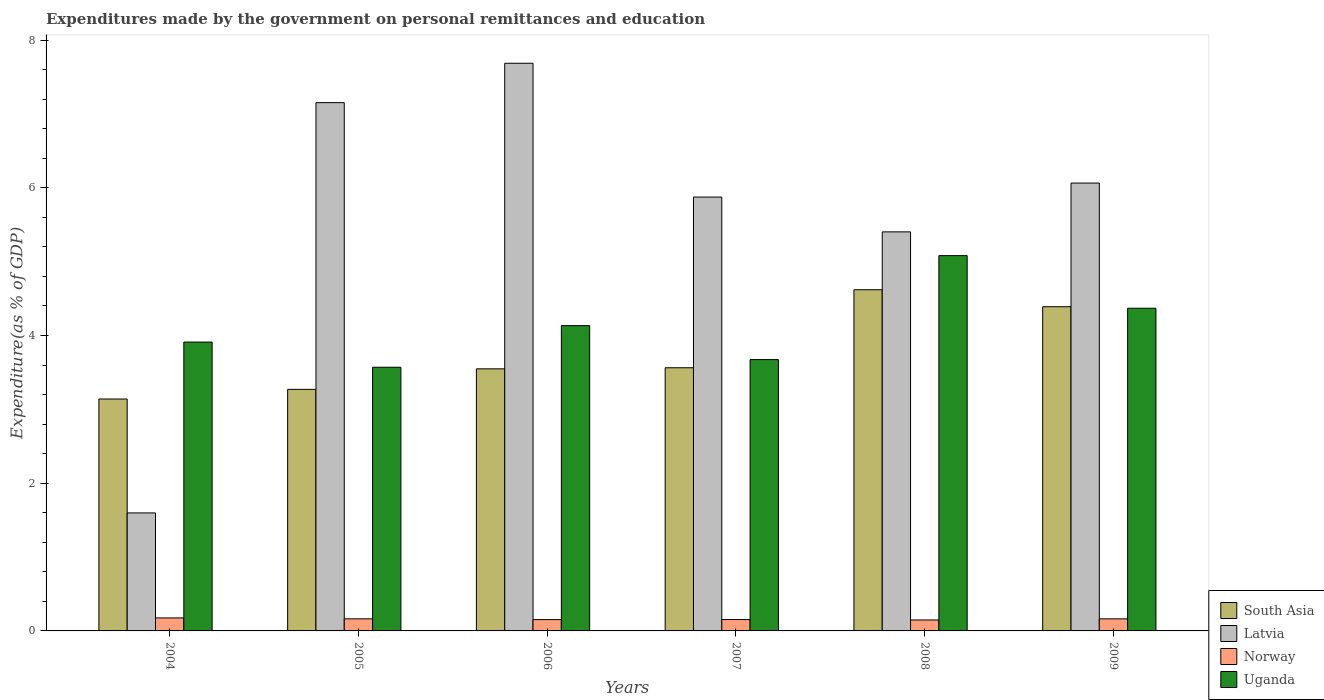Are the number of bars on each tick of the X-axis equal?
Provide a short and direct response. Yes. How many bars are there on the 1st tick from the right?
Provide a short and direct response. 4. In how many cases, is the number of bars for a given year not equal to the number of legend labels?
Give a very brief answer. 0. What is the expenditures made by the government on personal remittances and education in Norway in 2004?
Provide a short and direct response. 0.18. Across all years, what is the maximum expenditures made by the government on personal remittances and education in Latvia?
Provide a short and direct response. 7.69. Across all years, what is the minimum expenditures made by the government on personal remittances and education in Uganda?
Offer a very short reply. 3.57. In which year was the expenditures made by the government on personal remittances and education in Uganda maximum?
Your response must be concise. 2008. What is the total expenditures made by the government on personal remittances and education in Latvia in the graph?
Your response must be concise. 33.78. What is the difference between the expenditures made by the government on personal remittances and education in South Asia in 2004 and that in 2007?
Offer a very short reply. -0.42. What is the difference between the expenditures made by the government on personal remittances and education in Latvia in 2009 and the expenditures made by the government on personal remittances and education in Uganda in 2006?
Keep it short and to the point. 1.93. What is the average expenditures made by the government on personal remittances and education in Uganda per year?
Your answer should be very brief. 4.12. In the year 2008, what is the difference between the expenditures made by the government on personal remittances and education in Latvia and expenditures made by the government on personal remittances and education in South Asia?
Your response must be concise. 0.78. In how many years, is the expenditures made by the government on personal remittances and education in Latvia greater than 2.8 %?
Your answer should be very brief. 5. What is the ratio of the expenditures made by the government on personal remittances and education in Uganda in 2007 to that in 2008?
Make the answer very short. 0.72. Is the expenditures made by the government on personal remittances and education in South Asia in 2004 less than that in 2008?
Give a very brief answer. Yes. Is the difference between the expenditures made by the government on personal remittances and education in Latvia in 2004 and 2009 greater than the difference between the expenditures made by the government on personal remittances and education in South Asia in 2004 and 2009?
Provide a short and direct response. No. What is the difference between the highest and the second highest expenditures made by the government on personal remittances and education in South Asia?
Offer a very short reply. 0.23. What is the difference between the highest and the lowest expenditures made by the government on personal remittances and education in Latvia?
Provide a succinct answer. 6.09. What does the 3rd bar from the left in 2006 represents?
Keep it short and to the point. Norway. Is it the case that in every year, the sum of the expenditures made by the government on personal remittances and education in Latvia and expenditures made by the government on personal remittances and education in Norway is greater than the expenditures made by the government on personal remittances and education in Uganda?
Your answer should be compact. No. How many bars are there?
Keep it short and to the point. 24. How many years are there in the graph?
Offer a terse response. 6. Does the graph contain any zero values?
Provide a short and direct response. No. Does the graph contain grids?
Your answer should be compact. No. How many legend labels are there?
Your answer should be compact. 4. How are the legend labels stacked?
Give a very brief answer. Vertical. What is the title of the graph?
Your answer should be very brief. Expenditures made by the government on personal remittances and education. What is the label or title of the Y-axis?
Give a very brief answer. Expenditure(as % of GDP). What is the Expenditure(as % of GDP) in South Asia in 2004?
Keep it short and to the point. 3.14. What is the Expenditure(as % of GDP) of Latvia in 2004?
Offer a very short reply. 1.6. What is the Expenditure(as % of GDP) in Norway in 2004?
Provide a short and direct response. 0.18. What is the Expenditure(as % of GDP) in Uganda in 2004?
Offer a terse response. 3.91. What is the Expenditure(as % of GDP) of South Asia in 2005?
Ensure brevity in your answer.  3.27. What is the Expenditure(as % of GDP) of Latvia in 2005?
Offer a terse response. 7.15. What is the Expenditure(as % of GDP) of Norway in 2005?
Your answer should be compact. 0.16. What is the Expenditure(as % of GDP) of Uganda in 2005?
Make the answer very short. 3.57. What is the Expenditure(as % of GDP) in South Asia in 2006?
Provide a short and direct response. 3.55. What is the Expenditure(as % of GDP) of Latvia in 2006?
Make the answer very short. 7.69. What is the Expenditure(as % of GDP) in Norway in 2006?
Provide a succinct answer. 0.15. What is the Expenditure(as % of GDP) in Uganda in 2006?
Your answer should be very brief. 4.13. What is the Expenditure(as % of GDP) of South Asia in 2007?
Make the answer very short. 3.56. What is the Expenditure(as % of GDP) of Latvia in 2007?
Give a very brief answer. 5.87. What is the Expenditure(as % of GDP) of Norway in 2007?
Offer a very short reply. 0.15. What is the Expenditure(as % of GDP) in Uganda in 2007?
Offer a very short reply. 3.67. What is the Expenditure(as % of GDP) in South Asia in 2008?
Make the answer very short. 4.62. What is the Expenditure(as % of GDP) of Latvia in 2008?
Provide a short and direct response. 5.4. What is the Expenditure(as % of GDP) of Norway in 2008?
Provide a short and direct response. 0.15. What is the Expenditure(as % of GDP) of Uganda in 2008?
Give a very brief answer. 5.08. What is the Expenditure(as % of GDP) of South Asia in 2009?
Give a very brief answer. 4.39. What is the Expenditure(as % of GDP) in Latvia in 2009?
Your answer should be compact. 6.06. What is the Expenditure(as % of GDP) of Norway in 2009?
Offer a very short reply. 0.16. What is the Expenditure(as % of GDP) of Uganda in 2009?
Offer a very short reply. 4.37. Across all years, what is the maximum Expenditure(as % of GDP) of South Asia?
Offer a very short reply. 4.62. Across all years, what is the maximum Expenditure(as % of GDP) of Latvia?
Your answer should be very brief. 7.69. Across all years, what is the maximum Expenditure(as % of GDP) of Norway?
Give a very brief answer. 0.18. Across all years, what is the maximum Expenditure(as % of GDP) of Uganda?
Your answer should be compact. 5.08. Across all years, what is the minimum Expenditure(as % of GDP) of South Asia?
Offer a very short reply. 3.14. Across all years, what is the minimum Expenditure(as % of GDP) in Latvia?
Your answer should be compact. 1.6. Across all years, what is the minimum Expenditure(as % of GDP) of Norway?
Offer a terse response. 0.15. Across all years, what is the minimum Expenditure(as % of GDP) in Uganda?
Provide a succinct answer. 3.57. What is the total Expenditure(as % of GDP) in South Asia in the graph?
Your response must be concise. 22.53. What is the total Expenditure(as % of GDP) in Latvia in the graph?
Give a very brief answer. 33.78. What is the total Expenditure(as % of GDP) of Norway in the graph?
Offer a terse response. 0.96. What is the total Expenditure(as % of GDP) of Uganda in the graph?
Give a very brief answer. 24.74. What is the difference between the Expenditure(as % of GDP) of South Asia in 2004 and that in 2005?
Provide a short and direct response. -0.13. What is the difference between the Expenditure(as % of GDP) of Latvia in 2004 and that in 2005?
Offer a very short reply. -5.55. What is the difference between the Expenditure(as % of GDP) of Norway in 2004 and that in 2005?
Give a very brief answer. 0.01. What is the difference between the Expenditure(as % of GDP) in Uganda in 2004 and that in 2005?
Ensure brevity in your answer.  0.34. What is the difference between the Expenditure(as % of GDP) in South Asia in 2004 and that in 2006?
Your answer should be very brief. -0.41. What is the difference between the Expenditure(as % of GDP) in Latvia in 2004 and that in 2006?
Your answer should be very brief. -6.09. What is the difference between the Expenditure(as % of GDP) in Norway in 2004 and that in 2006?
Offer a very short reply. 0.02. What is the difference between the Expenditure(as % of GDP) of Uganda in 2004 and that in 2006?
Keep it short and to the point. -0.22. What is the difference between the Expenditure(as % of GDP) in South Asia in 2004 and that in 2007?
Keep it short and to the point. -0.42. What is the difference between the Expenditure(as % of GDP) in Latvia in 2004 and that in 2007?
Provide a succinct answer. -4.28. What is the difference between the Expenditure(as % of GDP) of Norway in 2004 and that in 2007?
Your answer should be compact. 0.02. What is the difference between the Expenditure(as % of GDP) of Uganda in 2004 and that in 2007?
Your answer should be very brief. 0.24. What is the difference between the Expenditure(as % of GDP) in South Asia in 2004 and that in 2008?
Your answer should be compact. -1.48. What is the difference between the Expenditure(as % of GDP) of Latvia in 2004 and that in 2008?
Make the answer very short. -3.81. What is the difference between the Expenditure(as % of GDP) of Norway in 2004 and that in 2008?
Your response must be concise. 0.03. What is the difference between the Expenditure(as % of GDP) in Uganda in 2004 and that in 2008?
Ensure brevity in your answer.  -1.17. What is the difference between the Expenditure(as % of GDP) of South Asia in 2004 and that in 2009?
Make the answer very short. -1.25. What is the difference between the Expenditure(as % of GDP) of Latvia in 2004 and that in 2009?
Provide a succinct answer. -4.47. What is the difference between the Expenditure(as % of GDP) of Norway in 2004 and that in 2009?
Your answer should be compact. 0.01. What is the difference between the Expenditure(as % of GDP) in Uganda in 2004 and that in 2009?
Provide a succinct answer. -0.46. What is the difference between the Expenditure(as % of GDP) of South Asia in 2005 and that in 2006?
Keep it short and to the point. -0.28. What is the difference between the Expenditure(as % of GDP) of Latvia in 2005 and that in 2006?
Provide a short and direct response. -0.53. What is the difference between the Expenditure(as % of GDP) in Norway in 2005 and that in 2006?
Keep it short and to the point. 0.01. What is the difference between the Expenditure(as % of GDP) of Uganda in 2005 and that in 2006?
Offer a very short reply. -0.56. What is the difference between the Expenditure(as % of GDP) of South Asia in 2005 and that in 2007?
Provide a succinct answer. -0.29. What is the difference between the Expenditure(as % of GDP) of Latvia in 2005 and that in 2007?
Your response must be concise. 1.28. What is the difference between the Expenditure(as % of GDP) of Norway in 2005 and that in 2007?
Keep it short and to the point. 0.01. What is the difference between the Expenditure(as % of GDP) of Uganda in 2005 and that in 2007?
Offer a very short reply. -0.1. What is the difference between the Expenditure(as % of GDP) of South Asia in 2005 and that in 2008?
Give a very brief answer. -1.35. What is the difference between the Expenditure(as % of GDP) in Latvia in 2005 and that in 2008?
Make the answer very short. 1.75. What is the difference between the Expenditure(as % of GDP) of Norway in 2005 and that in 2008?
Offer a very short reply. 0.02. What is the difference between the Expenditure(as % of GDP) in Uganda in 2005 and that in 2008?
Offer a terse response. -1.51. What is the difference between the Expenditure(as % of GDP) in South Asia in 2005 and that in 2009?
Your answer should be compact. -1.12. What is the difference between the Expenditure(as % of GDP) of Latvia in 2005 and that in 2009?
Keep it short and to the point. 1.09. What is the difference between the Expenditure(as % of GDP) in Norway in 2005 and that in 2009?
Your answer should be very brief. 0. What is the difference between the Expenditure(as % of GDP) in Uganda in 2005 and that in 2009?
Your answer should be very brief. -0.8. What is the difference between the Expenditure(as % of GDP) in South Asia in 2006 and that in 2007?
Provide a succinct answer. -0.01. What is the difference between the Expenditure(as % of GDP) of Latvia in 2006 and that in 2007?
Offer a very short reply. 1.81. What is the difference between the Expenditure(as % of GDP) in Norway in 2006 and that in 2007?
Keep it short and to the point. -0. What is the difference between the Expenditure(as % of GDP) in Uganda in 2006 and that in 2007?
Make the answer very short. 0.46. What is the difference between the Expenditure(as % of GDP) in South Asia in 2006 and that in 2008?
Your answer should be very brief. -1.07. What is the difference between the Expenditure(as % of GDP) of Latvia in 2006 and that in 2008?
Provide a succinct answer. 2.28. What is the difference between the Expenditure(as % of GDP) in Norway in 2006 and that in 2008?
Offer a very short reply. 0. What is the difference between the Expenditure(as % of GDP) of Uganda in 2006 and that in 2008?
Give a very brief answer. -0.95. What is the difference between the Expenditure(as % of GDP) in South Asia in 2006 and that in 2009?
Offer a terse response. -0.84. What is the difference between the Expenditure(as % of GDP) in Latvia in 2006 and that in 2009?
Provide a short and direct response. 1.62. What is the difference between the Expenditure(as % of GDP) of Norway in 2006 and that in 2009?
Offer a very short reply. -0.01. What is the difference between the Expenditure(as % of GDP) in Uganda in 2006 and that in 2009?
Give a very brief answer. -0.24. What is the difference between the Expenditure(as % of GDP) in South Asia in 2007 and that in 2008?
Make the answer very short. -1.06. What is the difference between the Expenditure(as % of GDP) of Latvia in 2007 and that in 2008?
Offer a terse response. 0.47. What is the difference between the Expenditure(as % of GDP) in Norway in 2007 and that in 2008?
Give a very brief answer. 0.01. What is the difference between the Expenditure(as % of GDP) of Uganda in 2007 and that in 2008?
Keep it short and to the point. -1.41. What is the difference between the Expenditure(as % of GDP) of South Asia in 2007 and that in 2009?
Offer a very short reply. -0.83. What is the difference between the Expenditure(as % of GDP) in Latvia in 2007 and that in 2009?
Give a very brief answer. -0.19. What is the difference between the Expenditure(as % of GDP) of Norway in 2007 and that in 2009?
Make the answer very short. -0.01. What is the difference between the Expenditure(as % of GDP) of Uganda in 2007 and that in 2009?
Offer a very short reply. -0.7. What is the difference between the Expenditure(as % of GDP) in South Asia in 2008 and that in 2009?
Offer a very short reply. 0.23. What is the difference between the Expenditure(as % of GDP) in Latvia in 2008 and that in 2009?
Make the answer very short. -0.66. What is the difference between the Expenditure(as % of GDP) of Norway in 2008 and that in 2009?
Offer a very short reply. -0.02. What is the difference between the Expenditure(as % of GDP) of Uganda in 2008 and that in 2009?
Provide a succinct answer. 0.71. What is the difference between the Expenditure(as % of GDP) of South Asia in 2004 and the Expenditure(as % of GDP) of Latvia in 2005?
Offer a terse response. -4.01. What is the difference between the Expenditure(as % of GDP) of South Asia in 2004 and the Expenditure(as % of GDP) of Norway in 2005?
Provide a short and direct response. 2.98. What is the difference between the Expenditure(as % of GDP) of South Asia in 2004 and the Expenditure(as % of GDP) of Uganda in 2005?
Your answer should be very brief. -0.43. What is the difference between the Expenditure(as % of GDP) in Latvia in 2004 and the Expenditure(as % of GDP) in Norway in 2005?
Provide a short and direct response. 1.43. What is the difference between the Expenditure(as % of GDP) in Latvia in 2004 and the Expenditure(as % of GDP) in Uganda in 2005?
Keep it short and to the point. -1.97. What is the difference between the Expenditure(as % of GDP) of Norway in 2004 and the Expenditure(as % of GDP) of Uganda in 2005?
Ensure brevity in your answer.  -3.39. What is the difference between the Expenditure(as % of GDP) in South Asia in 2004 and the Expenditure(as % of GDP) in Latvia in 2006?
Provide a succinct answer. -4.55. What is the difference between the Expenditure(as % of GDP) in South Asia in 2004 and the Expenditure(as % of GDP) in Norway in 2006?
Your answer should be very brief. 2.99. What is the difference between the Expenditure(as % of GDP) of South Asia in 2004 and the Expenditure(as % of GDP) of Uganda in 2006?
Your answer should be compact. -0.99. What is the difference between the Expenditure(as % of GDP) in Latvia in 2004 and the Expenditure(as % of GDP) in Norway in 2006?
Your response must be concise. 1.44. What is the difference between the Expenditure(as % of GDP) of Latvia in 2004 and the Expenditure(as % of GDP) of Uganda in 2006?
Your response must be concise. -2.54. What is the difference between the Expenditure(as % of GDP) in Norway in 2004 and the Expenditure(as % of GDP) in Uganda in 2006?
Keep it short and to the point. -3.96. What is the difference between the Expenditure(as % of GDP) of South Asia in 2004 and the Expenditure(as % of GDP) of Latvia in 2007?
Provide a succinct answer. -2.73. What is the difference between the Expenditure(as % of GDP) in South Asia in 2004 and the Expenditure(as % of GDP) in Norway in 2007?
Your answer should be compact. 2.99. What is the difference between the Expenditure(as % of GDP) in South Asia in 2004 and the Expenditure(as % of GDP) in Uganda in 2007?
Make the answer very short. -0.53. What is the difference between the Expenditure(as % of GDP) of Latvia in 2004 and the Expenditure(as % of GDP) of Norway in 2007?
Give a very brief answer. 1.44. What is the difference between the Expenditure(as % of GDP) of Latvia in 2004 and the Expenditure(as % of GDP) of Uganda in 2007?
Keep it short and to the point. -2.08. What is the difference between the Expenditure(as % of GDP) of Norway in 2004 and the Expenditure(as % of GDP) of Uganda in 2007?
Provide a succinct answer. -3.5. What is the difference between the Expenditure(as % of GDP) of South Asia in 2004 and the Expenditure(as % of GDP) of Latvia in 2008?
Provide a short and direct response. -2.26. What is the difference between the Expenditure(as % of GDP) in South Asia in 2004 and the Expenditure(as % of GDP) in Norway in 2008?
Provide a succinct answer. 2.99. What is the difference between the Expenditure(as % of GDP) in South Asia in 2004 and the Expenditure(as % of GDP) in Uganda in 2008?
Ensure brevity in your answer.  -1.94. What is the difference between the Expenditure(as % of GDP) in Latvia in 2004 and the Expenditure(as % of GDP) in Norway in 2008?
Your response must be concise. 1.45. What is the difference between the Expenditure(as % of GDP) in Latvia in 2004 and the Expenditure(as % of GDP) in Uganda in 2008?
Your answer should be very brief. -3.48. What is the difference between the Expenditure(as % of GDP) of Norway in 2004 and the Expenditure(as % of GDP) of Uganda in 2008?
Your answer should be compact. -4.91. What is the difference between the Expenditure(as % of GDP) of South Asia in 2004 and the Expenditure(as % of GDP) of Latvia in 2009?
Your answer should be very brief. -2.92. What is the difference between the Expenditure(as % of GDP) in South Asia in 2004 and the Expenditure(as % of GDP) in Norway in 2009?
Keep it short and to the point. 2.98. What is the difference between the Expenditure(as % of GDP) in South Asia in 2004 and the Expenditure(as % of GDP) in Uganda in 2009?
Your response must be concise. -1.23. What is the difference between the Expenditure(as % of GDP) in Latvia in 2004 and the Expenditure(as % of GDP) in Norway in 2009?
Provide a succinct answer. 1.43. What is the difference between the Expenditure(as % of GDP) in Latvia in 2004 and the Expenditure(as % of GDP) in Uganda in 2009?
Your answer should be compact. -2.77. What is the difference between the Expenditure(as % of GDP) of Norway in 2004 and the Expenditure(as % of GDP) of Uganda in 2009?
Offer a terse response. -4.19. What is the difference between the Expenditure(as % of GDP) in South Asia in 2005 and the Expenditure(as % of GDP) in Latvia in 2006?
Your response must be concise. -4.42. What is the difference between the Expenditure(as % of GDP) of South Asia in 2005 and the Expenditure(as % of GDP) of Norway in 2006?
Your answer should be compact. 3.12. What is the difference between the Expenditure(as % of GDP) in South Asia in 2005 and the Expenditure(as % of GDP) in Uganda in 2006?
Provide a succinct answer. -0.86. What is the difference between the Expenditure(as % of GDP) of Latvia in 2005 and the Expenditure(as % of GDP) of Norway in 2006?
Give a very brief answer. 7. What is the difference between the Expenditure(as % of GDP) in Latvia in 2005 and the Expenditure(as % of GDP) in Uganda in 2006?
Provide a succinct answer. 3.02. What is the difference between the Expenditure(as % of GDP) of Norway in 2005 and the Expenditure(as % of GDP) of Uganda in 2006?
Offer a terse response. -3.97. What is the difference between the Expenditure(as % of GDP) in South Asia in 2005 and the Expenditure(as % of GDP) in Latvia in 2007?
Provide a succinct answer. -2.6. What is the difference between the Expenditure(as % of GDP) of South Asia in 2005 and the Expenditure(as % of GDP) of Norway in 2007?
Offer a terse response. 3.12. What is the difference between the Expenditure(as % of GDP) of South Asia in 2005 and the Expenditure(as % of GDP) of Uganda in 2007?
Make the answer very short. -0.4. What is the difference between the Expenditure(as % of GDP) in Latvia in 2005 and the Expenditure(as % of GDP) in Norway in 2007?
Your answer should be compact. 7. What is the difference between the Expenditure(as % of GDP) of Latvia in 2005 and the Expenditure(as % of GDP) of Uganda in 2007?
Ensure brevity in your answer.  3.48. What is the difference between the Expenditure(as % of GDP) in Norway in 2005 and the Expenditure(as % of GDP) in Uganda in 2007?
Offer a terse response. -3.51. What is the difference between the Expenditure(as % of GDP) in South Asia in 2005 and the Expenditure(as % of GDP) in Latvia in 2008?
Keep it short and to the point. -2.13. What is the difference between the Expenditure(as % of GDP) of South Asia in 2005 and the Expenditure(as % of GDP) of Norway in 2008?
Ensure brevity in your answer.  3.12. What is the difference between the Expenditure(as % of GDP) of South Asia in 2005 and the Expenditure(as % of GDP) of Uganda in 2008?
Give a very brief answer. -1.81. What is the difference between the Expenditure(as % of GDP) in Latvia in 2005 and the Expenditure(as % of GDP) in Norway in 2008?
Your answer should be compact. 7. What is the difference between the Expenditure(as % of GDP) in Latvia in 2005 and the Expenditure(as % of GDP) in Uganda in 2008?
Your response must be concise. 2.07. What is the difference between the Expenditure(as % of GDP) in Norway in 2005 and the Expenditure(as % of GDP) in Uganda in 2008?
Offer a very short reply. -4.92. What is the difference between the Expenditure(as % of GDP) in South Asia in 2005 and the Expenditure(as % of GDP) in Latvia in 2009?
Keep it short and to the point. -2.79. What is the difference between the Expenditure(as % of GDP) of South Asia in 2005 and the Expenditure(as % of GDP) of Norway in 2009?
Make the answer very short. 3.11. What is the difference between the Expenditure(as % of GDP) in South Asia in 2005 and the Expenditure(as % of GDP) in Uganda in 2009?
Offer a terse response. -1.1. What is the difference between the Expenditure(as % of GDP) of Latvia in 2005 and the Expenditure(as % of GDP) of Norway in 2009?
Offer a terse response. 6.99. What is the difference between the Expenditure(as % of GDP) of Latvia in 2005 and the Expenditure(as % of GDP) of Uganda in 2009?
Your response must be concise. 2.78. What is the difference between the Expenditure(as % of GDP) in Norway in 2005 and the Expenditure(as % of GDP) in Uganda in 2009?
Ensure brevity in your answer.  -4.21. What is the difference between the Expenditure(as % of GDP) of South Asia in 2006 and the Expenditure(as % of GDP) of Latvia in 2007?
Provide a succinct answer. -2.33. What is the difference between the Expenditure(as % of GDP) in South Asia in 2006 and the Expenditure(as % of GDP) in Norway in 2007?
Offer a very short reply. 3.39. What is the difference between the Expenditure(as % of GDP) in South Asia in 2006 and the Expenditure(as % of GDP) in Uganda in 2007?
Provide a short and direct response. -0.12. What is the difference between the Expenditure(as % of GDP) in Latvia in 2006 and the Expenditure(as % of GDP) in Norway in 2007?
Make the answer very short. 7.53. What is the difference between the Expenditure(as % of GDP) in Latvia in 2006 and the Expenditure(as % of GDP) in Uganda in 2007?
Ensure brevity in your answer.  4.01. What is the difference between the Expenditure(as % of GDP) in Norway in 2006 and the Expenditure(as % of GDP) in Uganda in 2007?
Give a very brief answer. -3.52. What is the difference between the Expenditure(as % of GDP) in South Asia in 2006 and the Expenditure(as % of GDP) in Latvia in 2008?
Provide a succinct answer. -1.85. What is the difference between the Expenditure(as % of GDP) in South Asia in 2006 and the Expenditure(as % of GDP) in Norway in 2008?
Ensure brevity in your answer.  3.4. What is the difference between the Expenditure(as % of GDP) of South Asia in 2006 and the Expenditure(as % of GDP) of Uganda in 2008?
Provide a short and direct response. -1.53. What is the difference between the Expenditure(as % of GDP) of Latvia in 2006 and the Expenditure(as % of GDP) of Norway in 2008?
Provide a short and direct response. 7.54. What is the difference between the Expenditure(as % of GDP) in Latvia in 2006 and the Expenditure(as % of GDP) in Uganda in 2008?
Offer a very short reply. 2.6. What is the difference between the Expenditure(as % of GDP) of Norway in 2006 and the Expenditure(as % of GDP) of Uganda in 2008?
Provide a short and direct response. -4.93. What is the difference between the Expenditure(as % of GDP) of South Asia in 2006 and the Expenditure(as % of GDP) of Latvia in 2009?
Keep it short and to the point. -2.52. What is the difference between the Expenditure(as % of GDP) in South Asia in 2006 and the Expenditure(as % of GDP) in Norway in 2009?
Your response must be concise. 3.39. What is the difference between the Expenditure(as % of GDP) in South Asia in 2006 and the Expenditure(as % of GDP) in Uganda in 2009?
Your answer should be very brief. -0.82. What is the difference between the Expenditure(as % of GDP) in Latvia in 2006 and the Expenditure(as % of GDP) in Norway in 2009?
Your answer should be compact. 7.52. What is the difference between the Expenditure(as % of GDP) in Latvia in 2006 and the Expenditure(as % of GDP) in Uganda in 2009?
Provide a short and direct response. 3.32. What is the difference between the Expenditure(as % of GDP) of Norway in 2006 and the Expenditure(as % of GDP) of Uganda in 2009?
Provide a succinct answer. -4.22. What is the difference between the Expenditure(as % of GDP) in South Asia in 2007 and the Expenditure(as % of GDP) in Latvia in 2008?
Keep it short and to the point. -1.84. What is the difference between the Expenditure(as % of GDP) in South Asia in 2007 and the Expenditure(as % of GDP) in Norway in 2008?
Offer a terse response. 3.41. What is the difference between the Expenditure(as % of GDP) in South Asia in 2007 and the Expenditure(as % of GDP) in Uganda in 2008?
Keep it short and to the point. -1.52. What is the difference between the Expenditure(as % of GDP) in Latvia in 2007 and the Expenditure(as % of GDP) in Norway in 2008?
Give a very brief answer. 5.73. What is the difference between the Expenditure(as % of GDP) in Latvia in 2007 and the Expenditure(as % of GDP) in Uganda in 2008?
Ensure brevity in your answer.  0.79. What is the difference between the Expenditure(as % of GDP) of Norway in 2007 and the Expenditure(as % of GDP) of Uganda in 2008?
Provide a short and direct response. -4.93. What is the difference between the Expenditure(as % of GDP) of South Asia in 2007 and the Expenditure(as % of GDP) of Latvia in 2009?
Provide a short and direct response. -2.5. What is the difference between the Expenditure(as % of GDP) in South Asia in 2007 and the Expenditure(as % of GDP) in Norway in 2009?
Provide a short and direct response. 3.4. What is the difference between the Expenditure(as % of GDP) of South Asia in 2007 and the Expenditure(as % of GDP) of Uganda in 2009?
Your answer should be compact. -0.81. What is the difference between the Expenditure(as % of GDP) of Latvia in 2007 and the Expenditure(as % of GDP) of Norway in 2009?
Make the answer very short. 5.71. What is the difference between the Expenditure(as % of GDP) of Latvia in 2007 and the Expenditure(as % of GDP) of Uganda in 2009?
Provide a succinct answer. 1.51. What is the difference between the Expenditure(as % of GDP) in Norway in 2007 and the Expenditure(as % of GDP) in Uganda in 2009?
Provide a succinct answer. -4.22. What is the difference between the Expenditure(as % of GDP) in South Asia in 2008 and the Expenditure(as % of GDP) in Latvia in 2009?
Provide a succinct answer. -1.44. What is the difference between the Expenditure(as % of GDP) in South Asia in 2008 and the Expenditure(as % of GDP) in Norway in 2009?
Offer a very short reply. 4.46. What is the difference between the Expenditure(as % of GDP) of South Asia in 2008 and the Expenditure(as % of GDP) of Uganda in 2009?
Offer a terse response. 0.25. What is the difference between the Expenditure(as % of GDP) of Latvia in 2008 and the Expenditure(as % of GDP) of Norway in 2009?
Offer a terse response. 5.24. What is the difference between the Expenditure(as % of GDP) in Latvia in 2008 and the Expenditure(as % of GDP) in Uganda in 2009?
Your response must be concise. 1.03. What is the difference between the Expenditure(as % of GDP) of Norway in 2008 and the Expenditure(as % of GDP) of Uganda in 2009?
Your answer should be very brief. -4.22. What is the average Expenditure(as % of GDP) of South Asia per year?
Provide a short and direct response. 3.76. What is the average Expenditure(as % of GDP) of Latvia per year?
Ensure brevity in your answer.  5.63. What is the average Expenditure(as % of GDP) in Norway per year?
Give a very brief answer. 0.16. What is the average Expenditure(as % of GDP) in Uganda per year?
Provide a short and direct response. 4.12. In the year 2004, what is the difference between the Expenditure(as % of GDP) in South Asia and Expenditure(as % of GDP) in Latvia?
Provide a short and direct response. 1.54. In the year 2004, what is the difference between the Expenditure(as % of GDP) in South Asia and Expenditure(as % of GDP) in Norway?
Ensure brevity in your answer.  2.96. In the year 2004, what is the difference between the Expenditure(as % of GDP) of South Asia and Expenditure(as % of GDP) of Uganda?
Provide a succinct answer. -0.77. In the year 2004, what is the difference between the Expenditure(as % of GDP) of Latvia and Expenditure(as % of GDP) of Norway?
Provide a short and direct response. 1.42. In the year 2004, what is the difference between the Expenditure(as % of GDP) of Latvia and Expenditure(as % of GDP) of Uganda?
Ensure brevity in your answer.  -2.31. In the year 2004, what is the difference between the Expenditure(as % of GDP) of Norway and Expenditure(as % of GDP) of Uganda?
Offer a terse response. -3.73. In the year 2005, what is the difference between the Expenditure(as % of GDP) of South Asia and Expenditure(as % of GDP) of Latvia?
Provide a succinct answer. -3.88. In the year 2005, what is the difference between the Expenditure(as % of GDP) of South Asia and Expenditure(as % of GDP) of Norway?
Your response must be concise. 3.11. In the year 2005, what is the difference between the Expenditure(as % of GDP) in South Asia and Expenditure(as % of GDP) in Uganda?
Your answer should be compact. -0.3. In the year 2005, what is the difference between the Expenditure(as % of GDP) in Latvia and Expenditure(as % of GDP) in Norway?
Offer a very short reply. 6.99. In the year 2005, what is the difference between the Expenditure(as % of GDP) of Latvia and Expenditure(as % of GDP) of Uganda?
Keep it short and to the point. 3.58. In the year 2005, what is the difference between the Expenditure(as % of GDP) of Norway and Expenditure(as % of GDP) of Uganda?
Give a very brief answer. -3.41. In the year 2006, what is the difference between the Expenditure(as % of GDP) of South Asia and Expenditure(as % of GDP) of Latvia?
Provide a succinct answer. -4.14. In the year 2006, what is the difference between the Expenditure(as % of GDP) of South Asia and Expenditure(as % of GDP) of Norway?
Provide a succinct answer. 3.4. In the year 2006, what is the difference between the Expenditure(as % of GDP) in South Asia and Expenditure(as % of GDP) in Uganda?
Provide a succinct answer. -0.59. In the year 2006, what is the difference between the Expenditure(as % of GDP) in Latvia and Expenditure(as % of GDP) in Norway?
Make the answer very short. 7.53. In the year 2006, what is the difference between the Expenditure(as % of GDP) in Latvia and Expenditure(as % of GDP) in Uganda?
Offer a very short reply. 3.55. In the year 2006, what is the difference between the Expenditure(as % of GDP) of Norway and Expenditure(as % of GDP) of Uganda?
Make the answer very short. -3.98. In the year 2007, what is the difference between the Expenditure(as % of GDP) of South Asia and Expenditure(as % of GDP) of Latvia?
Your response must be concise. -2.31. In the year 2007, what is the difference between the Expenditure(as % of GDP) in South Asia and Expenditure(as % of GDP) in Norway?
Keep it short and to the point. 3.41. In the year 2007, what is the difference between the Expenditure(as % of GDP) in South Asia and Expenditure(as % of GDP) in Uganda?
Offer a terse response. -0.11. In the year 2007, what is the difference between the Expenditure(as % of GDP) of Latvia and Expenditure(as % of GDP) of Norway?
Make the answer very short. 5.72. In the year 2007, what is the difference between the Expenditure(as % of GDP) of Latvia and Expenditure(as % of GDP) of Uganda?
Your answer should be very brief. 2.2. In the year 2007, what is the difference between the Expenditure(as % of GDP) in Norway and Expenditure(as % of GDP) in Uganda?
Offer a terse response. -3.52. In the year 2008, what is the difference between the Expenditure(as % of GDP) in South Asia and Expenditure(as % of GDP) in Latvia?
Make the answer very short. -0.78. In the year 2008, what is the difference between the Expenditure(as % of GDP) in South Asia and Expenditure(as % of GDP) in Norway?
Keep it short and to the point. 4.47. In the year 2008, what is the difference between the Expenditure(as % of GDP) in South Asia and Expenditure(as % of GDP) in Uganda?
Give a very brief answer. -0.46. In the year 2008, what is the difference between the Expenditure(as % of GDP) of Latvia and Expenditure(as % of GDP) of Norway?
Ensure brevity in your answer.  5.25. In the year 2008, what is the difference between the Expenditure(as % of GDP) of Latvia and Expenditure(as % of GDP) of Uganda?
Your answer should be compact. 0.32. In the year 2008, what is the difference between the Expenditure(as % of GDP) of Norway and Expenditure(as % of GDP) of Uganda?
Keep it short and to the point. -4.93. In the year 2009, what is the difference between the Expenditure(as % of GDP) in South Asia and Expenditure(as % of GDP) in Latvia?
Provide a short and direct response. -1.67. In the year 2009, what is the difference between the Expenditure(as % of GDP) of South Asia and Expenditure(as % of GDP) of Norway?
Your answer should be very brief. 4.23. In the year 2009, what is the difference between the Expenditure(as % of GDP) in South Asia and Expenditure(as % of GDP) in Uganda?
Provide a short and direct response. 0.02. In the year 2009, what is the difference between the Expenditure(as % of GDP) in Latvia and Expenditure(as % of GDP) in Norway?
Offer a very short reply. 5.9. In the year 2009, what is the difference between the Expenditure(as % of GDP) in Latvia and Expenditure(as % of GDP) in Uganda?
Offer a very short reply. 1.69. In the year 2009, what is the difference between the Expenditure(as % of GDP) of Norway and Expenditure(as % of GDP) of Uganda?
Your answer should be very brief. -4.21. What is the ratio of the Expenditure(as % of GDP) in South Asia in 2004 to that in 2005?
Your answer should be very brief. 0.96. What is the ratio of the Expenditure(as % of GDP) in Latvia in 2004 to that in 2005?
Your response must be concise. 0.22. What is the ratio of the Expenditure(as % of GDP) in Norway in 2004 to that in 2005?
Provide a succinct answer. 1.07. What is the ratio of the Expenditure(as % of GDP) of Uganda in 2004 to that in 2005?
Keep it short and to the point. 1.1. What is the ratio of the Expenditure(as % of GDP) in South Asia in 2004 to that in 2006?
Offer a very short reply. 0.88. What is the ratio of the Expenditure(as % of GDP) in Latvia in 2004 to that in 2006?
Ensure brevity in your answer.  0.21. What is the ratio of the Expenditure(as % of GDP) in Norway in 2004 to that in 2006?
Ensure brevity in your answer.  1.15. What is the ratio of the Expenditure(as % of GDP) in Uganda in 2004 to that in 2006?
Offer a very short reply. 0.95. What is the ratio of the Expenditure(as % of GDP) in South Asia in 2004 to that in 2007?
Make the answer very short. 0.88. What is the ratio of the Expenditure(as % of GDP) in Latvia in 2004 to that in 2007?
Provide a short and direct response. 0.27. What is the ratio of the Expenditure(as % of GDP) of Norway in 2004 to that in 2007?
Offer a very short reply. 1.14. What is the ratio of the Expenditure(as % of GDP) in Uganda in 2004 to that in 2007?
Keep it short and to the point. 1.06. What is the ratio of the Expenditure(as % of GDP) of South Asia in 2004 to that in 2008?
Your answer should be very brief. 0.68. What is the ratio of the Expenditure(as % of GDP) of Latvia in 2004 to that in 2008?
Your response must be concise. 0.3. What is the ratio of the Expenditure(as % of GDP) in Norway in 2004 to that in 2008?
Offer a very short reply. 1.19. What is the ratio of the Expenditure(as % of GDP) of Uganda in 2004 to that in 2008?
Give a very brief answer. 0.77. What is the ratio of the Expenditure(as % of GDP) of South Asia in 2004 to that in 2009?
Give a very brief answer. 0.72. What is the ratio of the Expenditure(as % of GDP) in Latvia in 2004 to that in 2009?
Ensure brevity in your answer.  0.26. What is the ratio of the Expenditure(as % of GDP) of Norway in 2004 to that in 2009?
Offer a very short reply. 1.08. What is the ratio of the Expenditure(as % of GDP) in Uganda in 2004 to that in 2009?
Offer a very short reply. 0.9. What is the ratio of the Expenditure(as % of GDP) in South Asia in 2005 to that in 2006?
Give a very brief answer. 0.92. What is the ratio of the Expenditure(as % of GDP) in Latvia in 2005 to that in 2006?
Provide a short and direct response. 0.93. What is the ratio of the Expenditure(as % of GDP) of Norway in 2005 to that in 2006?
Give a very brief answer. 1.07. What is the ratio of the Expenditure(as % of GDP) of Uganda in 2005 to that in 2006?
Provide a succinct answer. 0.86. What is the ratio of the Expenditure(as % of GDP) in South Asia in 2005 to that in 2007?
Make the answer very short. 0.92. What is the ratio of the Expenditure(as % of GDP) in Latvia in 2005 to that in 2007?
Offer a terse response. 1.22. What is the ratio of the Expenditure(as % of GDP) of Norway in 2005 to that in 2007?
Your response must be concise. 1.06. What is the ratio of the Expenditure(as % of GDP) of Uganda in 2005 to that in 2007?
Provide a succinct answer. 0.97. What is the ratio of the Expenditure(as % of GDP) of South Asia in 2005 to that in 2008?
Make the answer very short. 0.71. What is the ratio of the Expenditure(as % of GDP) in Latvia in 2005 to that in 2008?
Ensure brevity in your answer.  1.32. What is the ratio of the Expenditure(as % of GDP) in Norway in 2005 to that in 2008?
Offer a very short reply. 1.1. What is the ratio of the Expenditure(as % of GDP) in Uganda in 2005 to that in 2008?
Your answer should be very brief. 0.7. What is the ratio of the Expenditure(as % of GDP) in South Asia in 2005 to that in 2009?
Give a very brief answer. 0.75. What is the ratio of the Expenditure(as % of GDP) of Latvia in 2005 to that in 2009?
Give a very brief answer. 1.18. What is the ratio of the Expenditure(as % of GDP) in Uganda in 2005 to that in 2009?
Your answer should be very brief. 0.82. What is the ratio of the Expenditure(as % of GDP) in Latvia in 2006 to that in 2007?
Make the answer very short. 1.31. What is the ratio of the Expenditure(as % of GDP) of Uganda in 2006 to that in 2007?
Your response must be concise. 1.13. What is the ratio of the Expenditure(as % of GDP) of South Asia in 2006 to that in 2008?
Make the answer very short. 0.77. What is the ratio of the Expenditure(as % of GDP) of Latvia in 2006 to that in 2008?
Provide a succinct answer. 1.42. What is the ratio of the Expenditure(as % of GDP) of Norway in 2006 to that in 2008?
Your answer should be very brief. 1.03. What is the ratio of the Expenditure(as % of GDP) of Uganda in 2006 to that in 2008?
Offer a very short reply. 0.81. What is the ratio of the Expenditure(as % of GDP) in South Asia in 2006 to that in 2009?
Give a very brief answer. 0.81. What is the ratio of the Expenditure(as % of GDP) in Latvia in 2006 to that in 2009?
Give a very brief answer. 1.27. What is the ratio of the Expenditure(as % of GDP) of Norway in 2006 to that in 2009?
Provide a short and direct response. 0.94. What is the ratio of the Expenditure(as % of GDP) in Uganda in 2006 to that in 2009?
Your answer should be compact. 0.95. What is the ratio of the Expenditure(as % of GDP) in South Asia in 2007 to that in 2008?
Offer a terse response. 0.77. What is the ratio of the Expenditure(as % of GDP) in Latvia in 2007 to that in 2008?
Offer a terse response. 1.09. What is the ratio of the Expenditure(as % of GDP) of Norway in 2007 to that in 2008?
Your answer should be very brief. 1.04. What is the ratio of the Expenditure(as % of GDP) in Uganda in 2007 to that in 2008?
Your response must be concise. 0.72. What is the ratio of the Expenditure(as % of GDP) in South Asia in 2007 to that in 2009?
Your answer should be compact. 0.81. What is the ratio of the Expenditure(as % of GDP) in Latvia in 2007 to that in 2009?
Your answer should be very brief. 0.97. What is the ratio of the Expenditure(as % of GDP) in Norway in 2007 to that in 2009?
Your answer should be compact. 0.94. What is the ratio of the Expenditure(as % of GDP) of Uganda in 2007 to that in 2009?
Offer a terse response. 0.84. What is the ratio of the Expenditure(as % of GDP) in South Asia in 2008 to that in 2009?
Provide a succinct answer. 1.05. What is the ratio of the Expenditure(as % of GDP) of Latvia in 2008 to that in 2009?
Offer a very short reply. 0.89. What is the ratio of the Expenditure(as % of GDP) of Norway in 2008 to that in 2009?
Provide a succinct answer. 0.91. What is the ratio of the Expenditure(as % of GDP) of Uganda in 2008 to that in 2009?
Provide a short and direct response. 1.16. What is the difference between the highest and the second highest Expenditure(as % of GDP) in South Asia?
Provide a succinct answer. 0.23. What is the difference between the highest and the second highest Expenditure(as % of GDP) in Latvia?
Ensure brevity in your answer.  0.53. What is the difference between the highest and the second highest Expenditure(as % of GDP) of Norway?
Give a very brief answer. 0.01. What is the difference between the highest and the second highest Expenditure(as % of GDP) in Uganda?
Make the answer very short. 0.71. What is the difference between the highest and the lowest Expenditure(as % of GDP) in South Asia?
Keep it short and to the point. 1.48. What is the difference between the highest and the lowest Expenditure(as % of GDP) in Latvia?
Your answer should be very brief. 6.09. What is the difference between the highest and the lowest Expenditure(as % of GDP) in Norway?
Ensure brevity in your answer.  0.03. What is the difference between the highest and the lowest Expenditure(as % of GDP) in Uganda?
Your answer should be very brief. 1.51. 